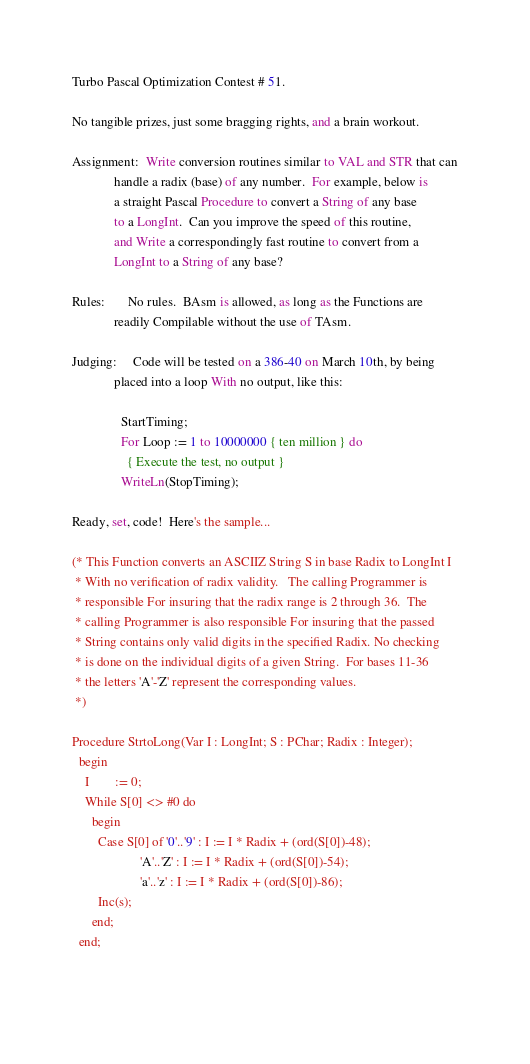Convert code to text. <code><loc_0><loc_0><loc_500><loc_500><_Pascal_>Turbo Pascal Optimization Contest # 51.

No tangible prizes, just some bragging rights, and a brain workout.

Assignment:  Write conversion routines similar to VAL and STR that can
             handle a radix (base) of any number.  For example, below is
             a straight Pascal Procedure to convert a String of any base
             to a LongInt.  Can you improve the speed of this routine,
             and Write a correspondingly fast routine to convert from a
             LongInt to a String of any base?

Rules:       No rules.  BAsm is allowed, as long as the Functions are
             readily Compilable without the use of TAsm.

Judging:     Code will be tested on a 386-40 on March 10th, by being
             placed into a loop With no output, like this:

               StartTiming;
               For Loop := 1 to 10000000 { ten million } do
                 { Execute the test, no output }
               WriteLn(StopTiming);

Ready, set, code!  Here's the sample...

(* This Function converts an ASCIIZ String S in base Radix to LongInt I
 * With no verification of radix validity.   The calling Programmer is
 * responsible For insuring that the radix range is 2 through 36.  The
 * calling Programmer is also responsible For insuring that the passed
 * String contains only valid digits in the specified Radix. No checking
 * is done on the individual digits of a given String.  For bases 11-36
 * the letters 'A'-'Z' represent the corresponding values.
 *)

Procedure StrtoLong(Var I : LongInt; S : PChar; Radix : Integer);
  begin
    I        := 0;
    While S[0] <> #0 do
      begin
        Case S[0] of '0'..'9' : I := I * Radix + (ord(S[0])-48);
                     'A'..'Z' : I := I * Radix + (ord(S[0])-54);
                     'a'..'z' : I := I * Radix + (ord(S[0])-86);
        Inc(s);
      end;
  end;

</code> 